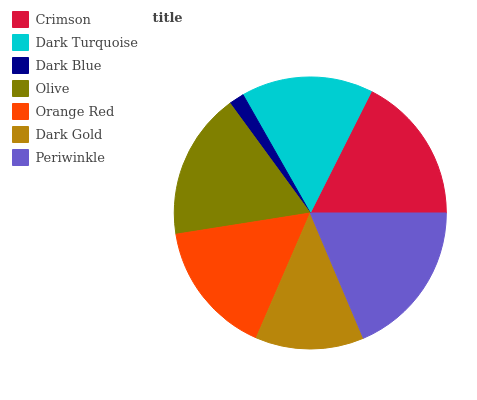Is Dark Blue the minimum?
Answer yes or no. Yes. Is Periwinkle the maximum?
Answer yes or no. Yes. Is Dark Turquoise the minimum?
Answer yes or no. No. Is Dark Turquoise the maximum?
Answer yes or no. No. Is Crimson greater than Dark Turquoise?
Answer yes or no. Yes. Is Dark Turquoise less than Crimson?
Answer yes or no. Yes. Is Dark Turquoise greater than Crimson?
Answer yes or no. No. Is Crimson less than Dark Turquoise?
Answer yes or no. No. Is Orange Red the high median?
Answer yes or no. Yes. Is Orange Red the low median?
Answer yes or no. Yes. Is Crimson the high median?
Answer yes or no. No. Is Olive the low median?
Answer yes or no. No. 